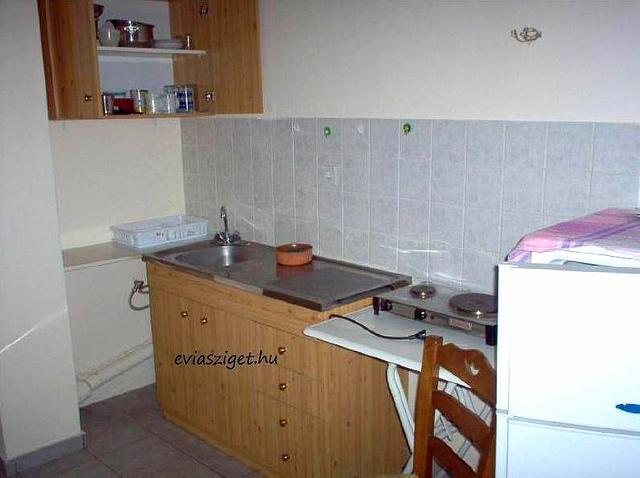How many people are wearing a yellow shirt?
Give a very brief answer. 0. 